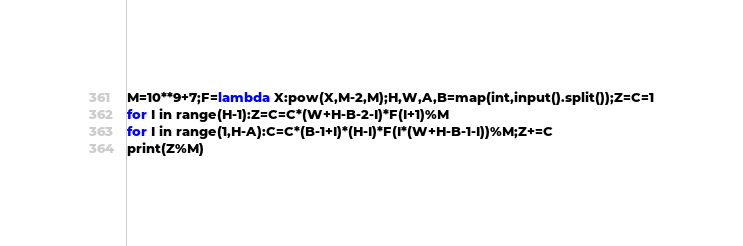<code> <loc_0><loc_0><loc_500><loc_500><_Python_>M=10**9+7;F=lambda X:pow(X,M-2,M);H,W,A,B=map(int,input().split());Z=C=1
for I in range(H-1):Z=C=C*(W+H-B-2-I)*F(I+1)%M
for I in range(1,H-A):C=C*(B-1+I)*(H-I)*F(I*(W+H-B-1-I))%M;Z+=C
print(Z%M)
</code> 